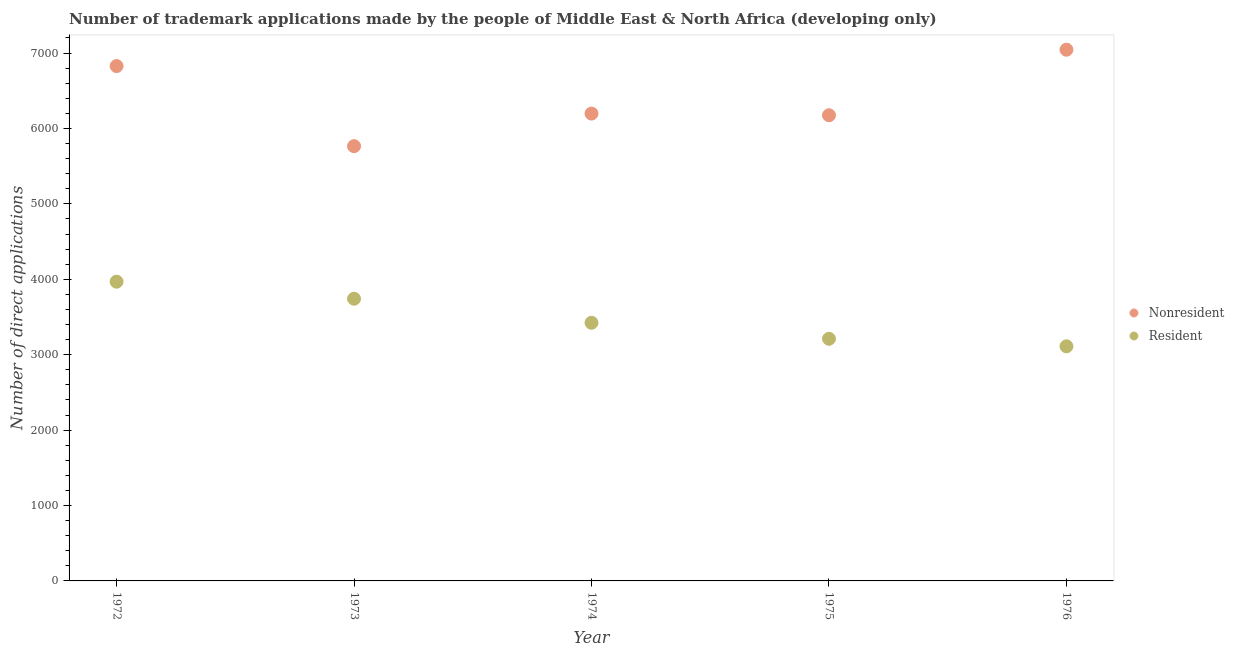Is the number of dotlines equal to the number of legend labels?
Give a very brief answer. Yes. What is the number of trademark applications made by residents in 1973?
Keep it short and to the point. 3742. Across all years, what is the maximum number of trademark applications made by residents?
Provide a short and direct response. 3968. Across all years, what is the minimum number of trademark applications made by non residents?
Keep it short and to the point. 5765. In which year was the number of trademark applications made by non residents maximum?
Ensure brevity in your answer.  1976. In which year was the number of trademark applications made by residents minimum?
Make the answer very short. 1976. What is the total number of trademark applications made by residents in the graph?
Your answer should be compact. 1.75e+04. What is the difference between the number of trademark applications made by non residents in 1974 and that in 1976?
Ensure brevity in your answer.  -847. What is the difference between the number of trademark applications made by non residents in 1975 and the number of trademark applications made by residents in 1972?
Your response must be concise. 2207. What is the average number of trademark applications made by residents per year?
Provide a succinct answer. 3491. In the year 1972, what is the difference between the number of trademark applications made by non residents and number of trademark applications made by residents?
Give a very brief answer. 2859. What is the ratio of the number of trademark applications made by residents in 1972 to that in 1975?
Your response must be concise. 1.24. What is the difference between the highest and the second highest number of trademark applications made by non residents?
Give a very brief answer. 217. What is the difference between the highest and the lowest number of trademark applications made by non residents?
Offer a terse response. 1279. Does the number of trademark applications made by residents monotonically increase over the years?
Provide a succinct answer. No. What is the difference between two consecutive major ticks on the Y-axis?
Provide a succinct answer. 1000. Does the graph contain grids?
Provide a succinct answer. No. Where does the legend appear in the graph?
Offer a very short reply. Center right. What is the title of the graph?
Your response must be concise. Number of trademark applications made by the people of Middle East & North Africa (developing only). Does "Passenger Transport Items" appear as one of the legend labels in the graph?
Make the answer very short. No. What is the label or title of the X-axis?
Provide a short and direct response. Year. What is the label or title of the Y-axis?
Your answer should be very brief. Number of direct applications. What is the Number of direct applications of Nonresident in 1972?
Your answer should be very brief. 6827. What is the Number of direct applications of Resident in 1972?
Offer a very short reply. 3968. What is the Number of direct applications in Nonresident in 1973?
Your response must be concise. 5765. What is the Number of direct applications of Resident in 1973?
Ensure brevity in your answer.  3742. What is the Number of direct applications of Nonresident in 1974?
Give a very brief answer. 6197. What is the Number of direct applications in Resident in 1974?
Provide a succinct answer. 3423. What is the Number of direct applications in Nonresident in 1975?
Offer a terse response. 6175. What is the Number of direct applications of Resident in 1975?
Keep it short and to the point. 3211. What is the Number of direct applications in Nonresident in 1976?
Your answer should be compact. 7044. What is the Number of direct applications of Resident in 1976?
Your answer should be compact. 3111. Across all years, what is the maximum Number of direct applications in Nonresident?
Make the answer very short. 7044. Across all years, what is the maximum Number of direct applications in Resident?
Ensure brevity in your answer.  3968. Across all years, what is the minimum Number of direct applications of Nonresident?
Make the answer very short. 5765. Across all years, what is the minimum Number of direct applications of Resident?
Ensure brevity in your answer.  3111. What is the total Number of direct applications in Nonresident in the graph?
Keep it short and to the point. 3.20e+04. What is the total Number of direct applications of Resident in the graph?
Keep it short and to the point. 1.75e+04. What is the difference between the Number of direct applications in Nonresident in 1972 and that in 1973?
Provide a short and direct response. 1062. What is the difference between the Number of direct applications in Resident in 1972 and that in 1973?
Provide a short and direct response. 226. What is the difference between the Number of direct applications in Nonresident in 1972 and that in 1974?
Keep it short and to the point. 630. What is the difference between the Number of direct applications of Resident in 1972 and that in 1974?
Offer a terse response. 545. What is the difference between the Number of direct applications of Nonresident in 1972 and that in 1975?
Your answer should be very brief. 652. What is the difference between the Number of direct applications in Resident in 1972 and that in 1975?
Keep it short and to the point. 757. What is the difference between the Number of direct applications in Nonresident in 1972 and that in 1976?
Your answer should be very brief. -217. What is the difference between the Number of direct applications in Resident in 1972 and that in 1976?
Offer a very short reply. 857. What is the difference between the Number of direct applications in Nonresident in 1973 and that in 1974?
Offer a terse response. -432. What is the difference between the Number of direct applications in Resident in 1973 and that in 1974?
Your answer should be very brief. 319. What is the difference between the Number of direct applications of Nonresident in 1973 and that in 1975?
Make the answer very short. -410. What is the difference between the Number of direct applications in Resident in 1973 and that in 1975?
Provide a short and direct response. 531. What is the difference between the Number of direct applications of Nonresident in 1973 and that in 1976?
Provide a short and direct response. -1279. What is the difference between the Number of direct applications in Resident in 1973 and that in 1976?
Offer a very short reply. 631. What is the difference between the Number of direct applications in Resident in 1974 and that in 1975?
Keep it short and to the point. 212. What is the difference between the Number of direct applications in Nonresident in 1974 and that in 1976?
Provide a short and direct response. -847. What is the difference between the Number of direct applications of Resident in 1974 and that in 1976?
Your answer should be compact. 312. What is the difference between the Number of direct applications in Nonresident in 1975 and that in 1976?
Your answer should be compact. -869. What is the difference between the Number of direct applications of Resident in 1975 and that in 1976?
Make the answer very short. 100. What is the difference between the Number of direct applications in Nonresident in 1972 and the Number of direct applications in Resident in 1973?
Keep it short and to the point. 3085. What is the difference between the Number of direct applications of Nonresident in 1972 and the Number of direct applications of Resident in 1974?
Offer a terse response. 3404. What is the difference between the Number of direct applications in Nonresident in 1972 and the Number of direct applications in Resident in 1975?
Keep it short and to the point. 3616. What is the difference between the Number of direct applications of Nonresident in 1972 and the Number of direct applications of Resident in 1976?
Your answer should be compact. 3716. What is the difference between the Number of direct applications in Nonresident in 1973 and the Number of direct applications in Resident in 1974?
Offer a very short reply. 2342. What is the difference between the Number of direct applications in Nonresident in 1973 and the Number of direct applications in Resident in 1975?
Your answer should be very brief. 2554. What is the difference between the Number of direct applications in Nonresident in 1973 and the Number of direct applications in Resident in 1976?
Provide a short and direct response. 2654. What is the difference between the Number of direct applications in Nonresident in 1974 and the Number of direct applications in Resident in 1975?
Make the answer very short. 2986. What is the difference between the Number of direct applications of Nonresident in 1974 and the Number of direct applications of Resident in 1976?
Keep it short and to the point. 3086. What is the difference between the Number of direct applications in Nonresident in 1975 and the Number of direct applications in Resident in 1976?
Give a very brief answer. 3064. What is the average Number of direct applications of Nonresident per year?
Your answer should be very brief. 6401.6. What is the average Number of direct applications of Resident per year?
Provide a succinct answer. 3491. In the year 1972, what is the difference between the Number of direct applications of Nonresident and Number of direct applications of Resident?
Offer a terse response. 2859. In the year 1973, what is the difference between the Number of direct applications of Nonresident and Number of direct applications of Resident?
Provide a short and direct response. 2023. In the year 1974, what is the difference between the Number of direct applications of Nonresident and Number of direct applications of Resident?
Your response must be concise. 2774. In the year 1975, what is the difference between the Number of direct applications in Nonresident and Number of direct applications in Resident?
Offer a terse response. 2964. In the year 1976, what is the difference between the Number of direct applications of Nonresident and Number of direct applications of Resident?
Your response must be concise. 3933. What is the ratio of the Number of direct applications of Nonresident in 1972 to that in 1973?
Keep it short and to the point. 1.18. What is the ratio of the Number of direct applications of Resident in 1972 to that in 1973?
Give a very brief answer. 1.06. What is the ratio of the Number of direct applications of Nonresident in 1972 to that in 1974?
Ensure brevity in your answer.  1.1. What is the ratio of the Number of direct applications of Resident in 1972 to that in 1974?
Your answer should be very brief. 1.16. What is the ratio of the Number of direct applications in Nonresident in 1972 to that in 1975?
Keep it short and to the point. 1.11. What is the ratio of the Number of direct applications in Resident in 1972 to that in 1975?
Offer a terse response. 1.24. What is the ratio of the Number of direct applications of Nonresident in 1972 to that in 1976?
Provide a succinct answer. 0.97. What is the ratio of the Number of direct applications in Resident in 1972 to that in 1976?
Your answer should be very brief. 1.28. What is the ratio of the Number of direct applications of Nonresident in 1973 to that in 1974?
Your answer should be compact. 0.93. What is the ratio of the Number of direct applications of Resident in 1973 to that in 1974?
Ensure brevity in your answer.  1.09. What is the ratio of the Number of direct applications of Nonresident in 1973 to that in 1975?
Your answer should be very brief. 0.93. What is the ratio of the Number of direct applications of Resident in 1973 to that in 1975?
Give a very brief answer. 1.17. What is the ratio of the Number of direct applications of Nonresident in 1973 to that in 1976?
Keep it short and to the point. 0.82. What is the ratio of the Number of direct applications in Resident in 1973 to that in 1976?
Your response must be concise. 1.2. What is the ratio of the Number of direct applications in Nonresident in 1974 to that in 1975?
Offer a terse response. 1. What is the ratio of the Number of direct applications of Resident in 1974 to that in 1975?
Ensure brevity in your answer.  1.07. What is the ratio of the Number of direct applications of Nonresident in 1974 to that in 1976?
Make the answer very short. 0.88. What is the ratio of the Number of direct applications of Resident in 1974 to that in 1976?
Your response must be concise. 1.1. What is the ratio of the Number of direct applications in Nonresident in 1975 to that in 1976?
Your response must be concise. 0.88. What is the ratio of the Number of direct applications of Resident in 1975 to that in 1976?
Provide a succinct answer. 1.03. What is the difference between the highest and the second highest Number of direct applications of Nonresident?
Ensure brevity in your answer.  217. What is the difference between the highest and the second highest Number of direct applications in Resident?
Provide a short and direct response. 226. What is the difference between the highest and the lowest Number of direct applications of Nonresident?
Your answer should be compact. 1279. What is the difference between the highest and the lowest Number of direct applications in Resident?
Offer a very short reply. 857. 